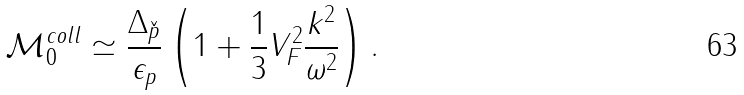<formula> <loc_0><loc_0><loc_500><loc_500>\mathcal { M } _ { 0 } ^ { c o l l } \simeq \frac { \Delta _ { \check { p } } } { \epsilon _ { p } } \left ( 1 + \frac { 1 } { 3 } V _ { F } ^ { 2 } \frac { k ^ { 2 } } { \omega ^ { 2 } } \right ) .</formula> 